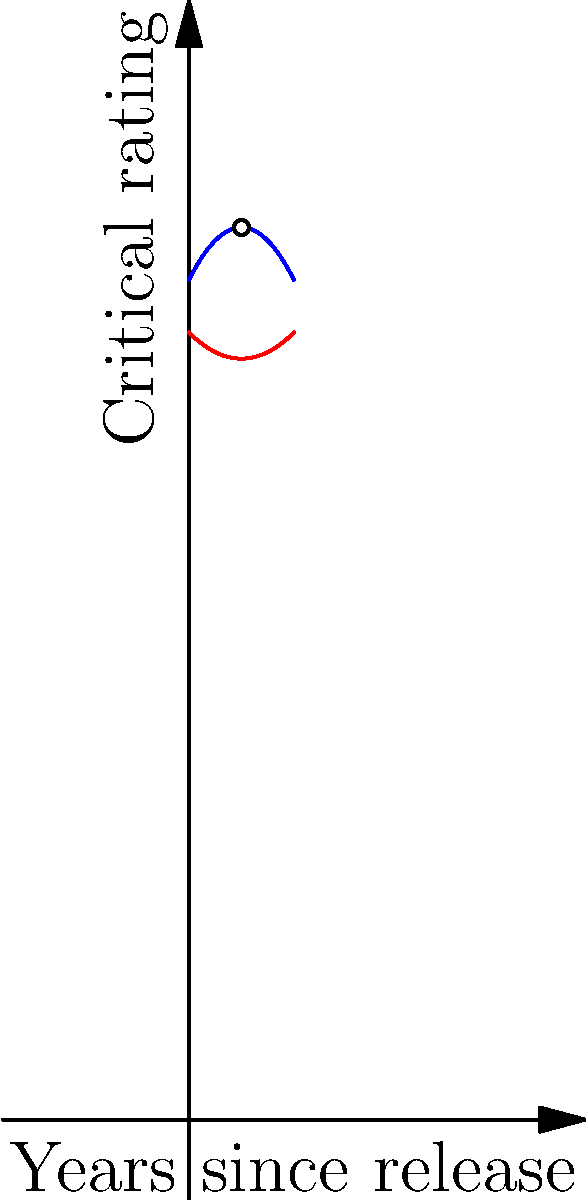The graph above shows the critical ratings of classic and modern films over time. The blue curve represents classic films, while the red curve represents modern films. The functions for these curves are:

Classic films: $f(x) = -0.2x^2 + 2x + 80$
Modern films: $g(x) = 0.1x^2 - x + 75$

Where $x$ represents the number of years since the film's release.

At what point (in years) do the critical ratings of classic and modern films intersect, and what is their rating at this point? To find the intersection point, we need to solve the equation:

$f(x) = g(x)$

$-0.2x^2 + 2x + 80 = 0.1x^2 - x + 75$

Rearranging the terms:
$-0.3x^2 + 3x + 5 = 0$

This is a quadratic equation. We can solve it using the quadratic formula:
$x = \frac{-b \pm \sqrt{b^2 - 4ac}}{2a}$

Where $a = -0.3$, $b = 3$, and $c = 5$

$x = \frac{-3 \pm \sqrt{3^2 - 4(-0.3)(5)}}{2(-0.3)}$

$x = \frac{-3 \pm \sqrt{9 + 6}}{-0.6}$

$x = \frac{-3 \pm \sqrt{15}}{-0.6}$

This gives us two solutions: $x \approx 5$ and $x \approx 3.33$

Since we're only interested in the positive solution within our graph's range, we'll use $x = 5$.

To find the rating at this point, we can substitute $x = 5$ into either function:

$f(5) = -0.2(5)^2 + 2(5) + 80 = -5 + 10 + 80 = 85$

Therefore, the critical ratings intersect 5 years after release, with a rating of 85.
Answer: (5, 85) 